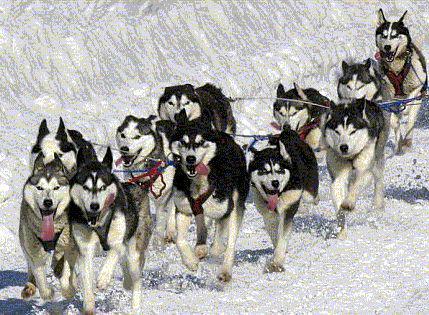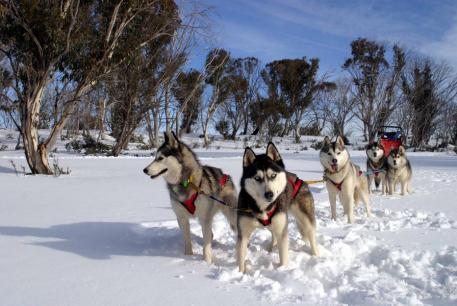The first image is the image on the left, the second image is the image on the right. For the images shown, is this caption "The image on the left has more than six dogs pulling the sleigh." true? Answer yes or no. Yes. The first image is the image on the left, the second image is the image on the right. Given the left and right images, does the statement "There is a person visible behind a pack of huskies." hold true? Answer yes or no. No. 